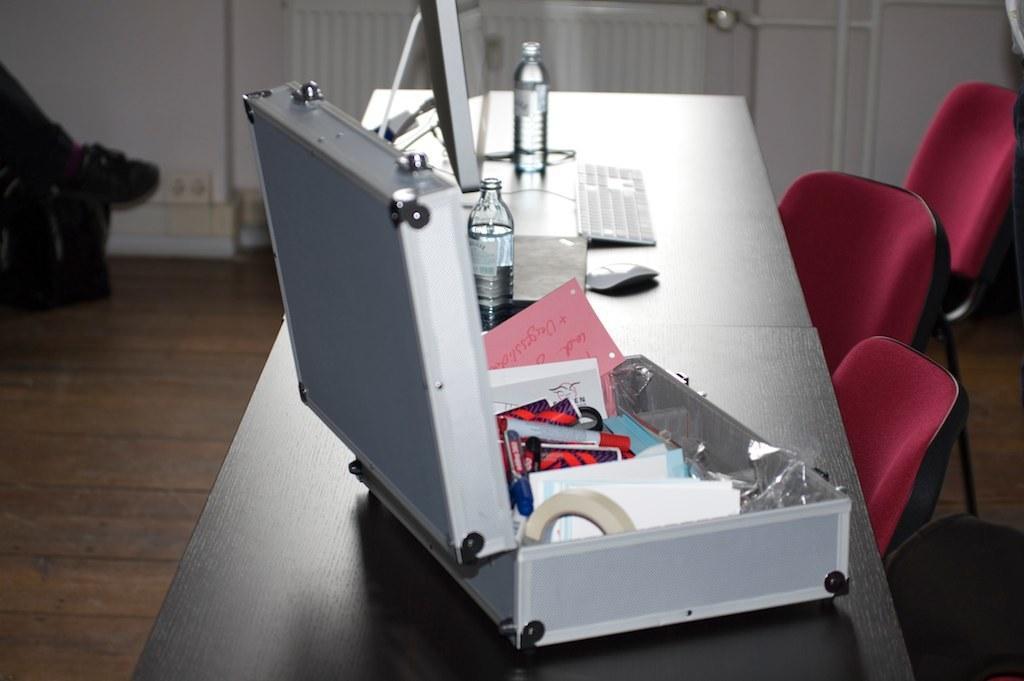Could you give a brief overview of what you see in this image? In this image, we can see a table with some objects like bottles, a keyboard and a mouse. There are a few chairs. We can see a person's leg on the left. We can see the ground with an object. We can see the wall and some white colored poles. 